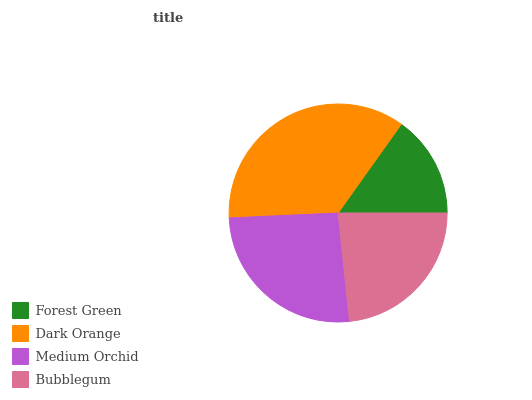Is Forest Green the minimum?
Answer yes or no. Yes. Is Dark Orange the maximum?
Answer yes or no. Yes. Is Medium Orchid the minimum?
Answer yes or no. No. Is Medium Orchid the maximum?
Answer yes or no. No. Is Dark Orange greater than Medium Orchid?
Answer yes or no. Yes. Is Medium Orchid less than Dark Orange?
Answer yes or no. Yes. Is Medium Orchid greater than Dark Orange?
Answer yes or no. No. Is Dark Orange less than Medium Orchid?
Answer yes or no. No. Is Medium Orchid the high median?
Answer yes or no. Yes. Is Bubblegum the low median?
Answer yes or no. Yes. Is Bubblegum the high median?
Answer yes or no. No. Is Dark Orange the low median?
Answer yes or no. No. 